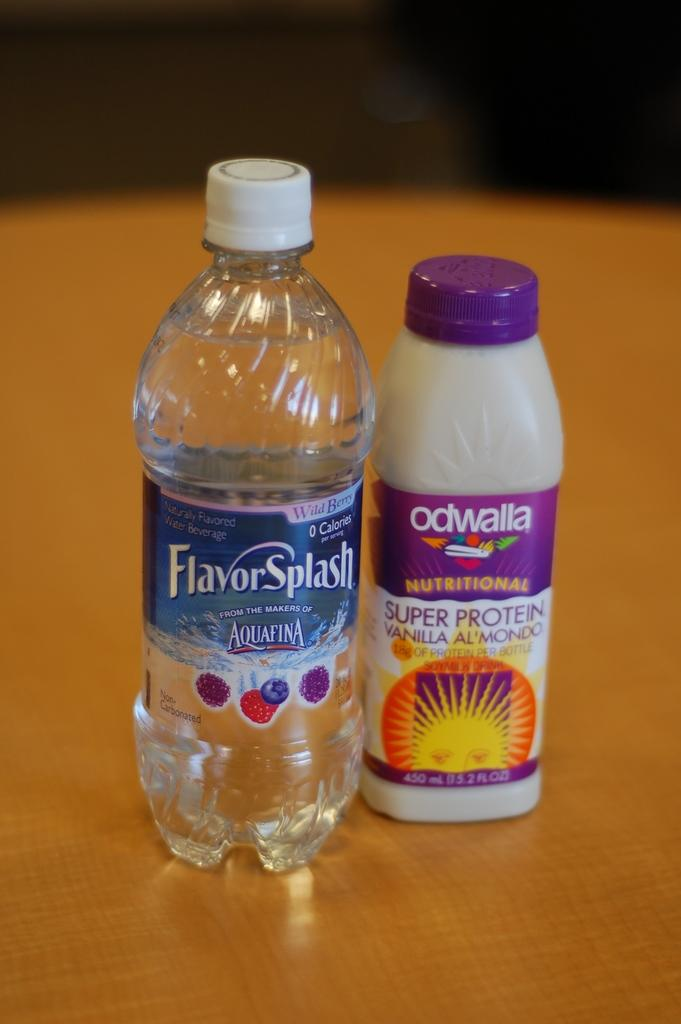Provide a one-sentence caption for the provided image. A bottle of water claims to have a Flavor Splash. 